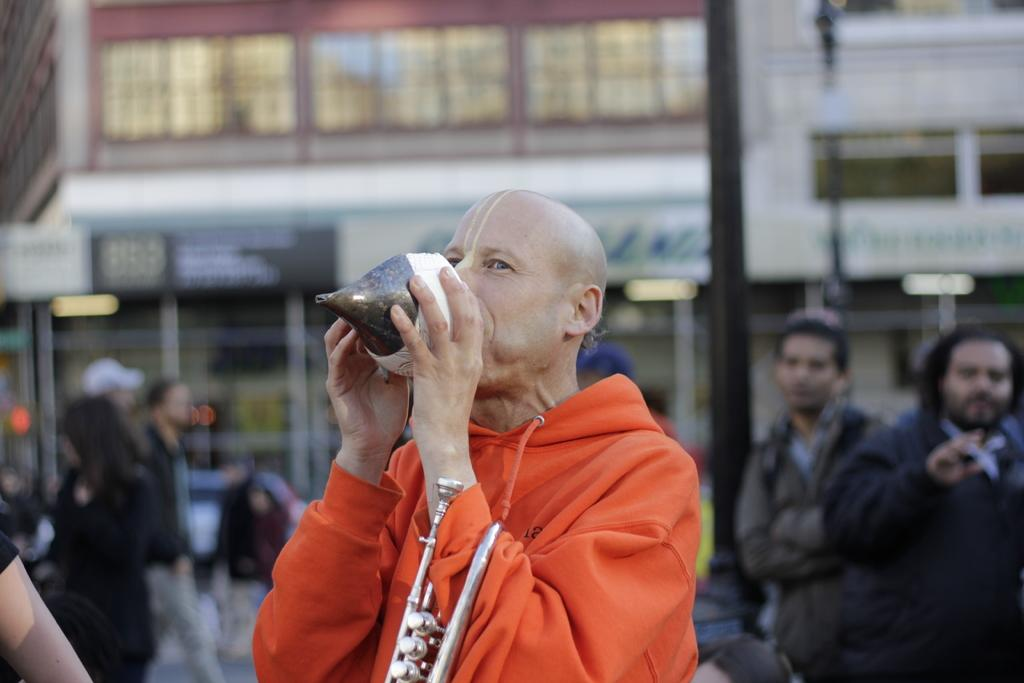What is the person in the image doing? The person in the image is blowing a shell. Are there any other people in the image? Yes, there are other people visible in the image. What type of plant is being used as a bookmark in the image? There is no plant or bookmark present in the image; it features a person blowing a shell and other people. 